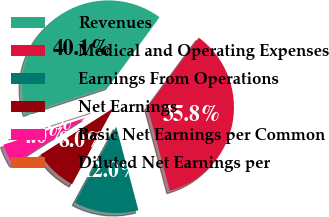Convert chart to OTSL. <chart><loc_0><loc_0><loc_500><loc_500><pie_chart><fcel>Revenues<fcel>Medical and Operating Expenses<fcel>Earnings From Operations<fcel>Net Earnings<fcel>Basic Net Earnings per Common<fcel>Diluted Net Earnings per<nl><fcel>40.13%<fcel>35.77%<fcel>12.04%<fcel>8.03%<fcel>4.02%<fcel>0.0%<nl></chart> 